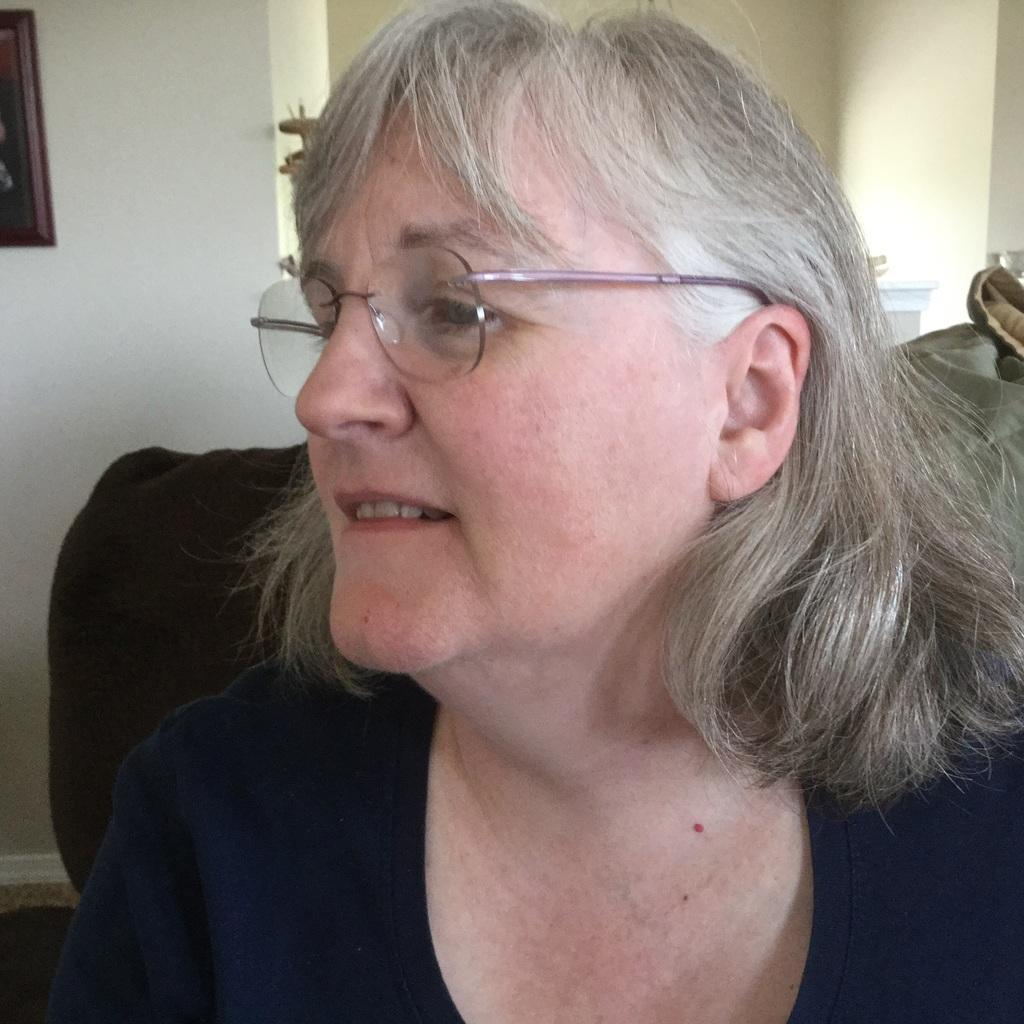Who is the main subject in the image? There is a woman in the image. What is the woman doing in the image? The woman is seated on a chair. What accessory is the woman wearing in the image? The woman is wearing spectacles. What can be seen on the wall in the image? There is a photo frame on the wall in the image. What type of wrench is the woman holding in the image? There is no wrench present in the image; the woman is wearing spectacles and seated on a chair. 